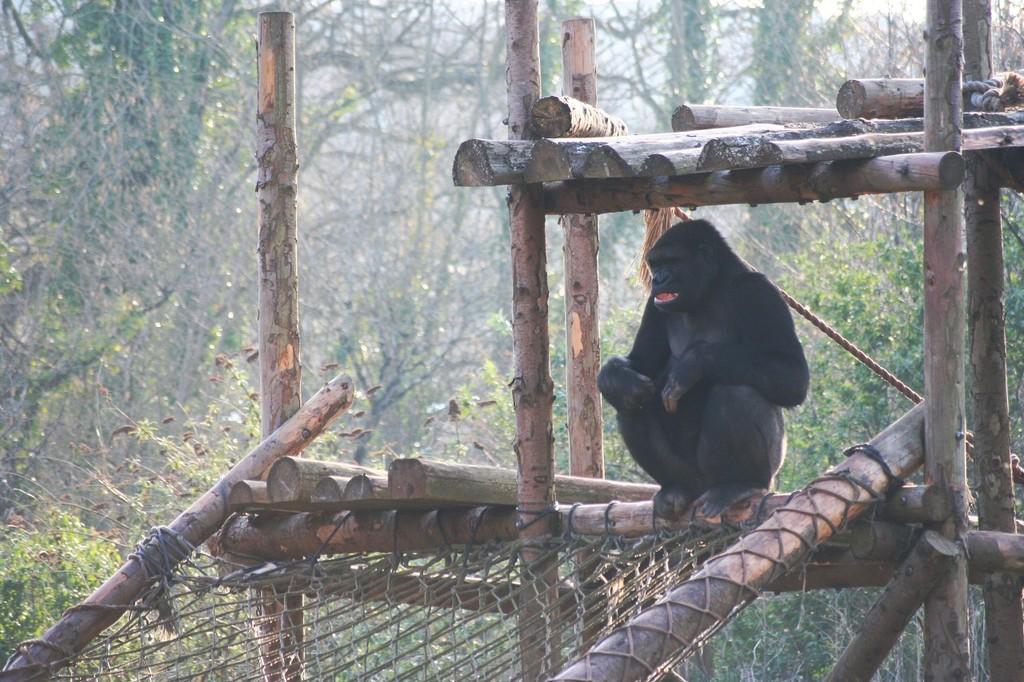Can you describe this image briefly? In this image, we can see a monkey sitting in the wooden shed, in the background, we can see some trees. 